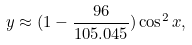<formula> <loc_0><loc_0><loc_500><loc_500>y \approx ( 1 - \frac { 9 6 } { 1 0 5 . 0 4 5 } ) \cos ^ { 2 } x ,</formula> 